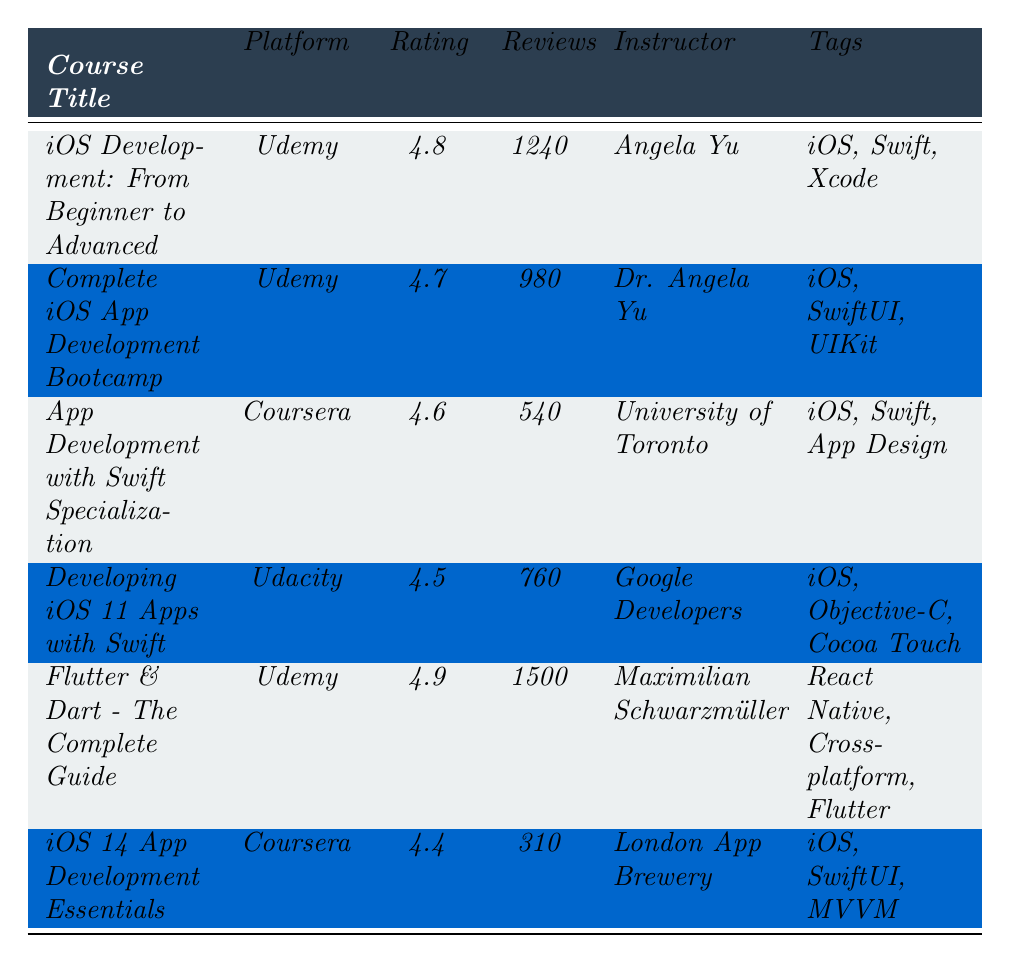What is the highest rating among the listed courses? The highest rating can be found by comparing the ratings of all courses in the table. The courses have ratings of 4.8, 4.7, 4.6, 4.5, 4.9, and 4.4. The highest value is 4.9, which belongs to the course "Flutter & Dart - The Complete Guide."
Answer: 4.9 Which platform has the most courses listed in the table? To find the platform with the most courses, we count how many times each platform appears in the table. Udemy appears four times, Coursera appears twice, and Udacity appears once. Therefore, Udemy has the most courses listed.
Answer: Udemy What is the average rating of all courses listed in the table? First, we add up all the ratings: 4.8 + 4.7 + 4.6 + 4.5 + 4.9 + 4.4 = 29.9. There are 6 courses, so we divide the total rating by the number of courses, which gives us 29.9 / 6 = 4.9833. Rounding to one decimal place, the average rating is 4.8.
Answer: 4.8 Are there any courses taught by the same instructor? By examining the "Instructor" column, we see that the courses "iOS Development: From Beginner to Advanced" and "Complete iOS App Development Bootcamp" are both taught by Angela Yu and Dr. Angela Yu. This indicates that there are course offerings from the same instructor.
Answer: Yes Which course has the least number of reviews? To find the course with the least reviews, we look at the "Reviews" column and get the values: 1240, 980, 540, 760, 1500, and 310. The smallest value is 310, corresponding to "iOS 14 App Development Essentials."
Answer: iOS 14 App Development Essentials What is the difference in average ratings between courses on Udemy and Coursera? First, we calculate the average rating for Udemy courses: (4.8 + 4.7 + 4.9) / 3 = 4.8. For Coursera, the ratings are (4.6 + 4.4) / 2 = 4.5. The difference is 4.8 - 4.5 = 0.3.
Answer: 0.3 Which course has the highest number of reviews and what is that number? By looking at the "Reviews" column, the reviews are: 1240, 980, 540, 760, 1500, and 310. The highest number is 1500, which belongs to the course "Flutter & Dart - The Complete Guide."
Answer: 1500 Are all courses rated above 4.0? We check each course rating: 4.8, 4.7, 4.6, 4.5, 4.9, and 4.4. Since all ratings are above 4.0, we can conclude that each course maintains a rating above this threshold.
Answer: Yes How many different tags are used across all courses? The tags for the courses are: iOS, Swift, Xcode, SwiftUI, UIKit, App Design, Objective-C, Cocoa Touch, React Native, Cross-platform, Flutter, and MVVM. Counting these unique tags gives us a total of 11 distinct tags.
Answer: 11 What proportion of the total reviews come from the course with the most reviews? The total number of reviews is 1240 + 980 + 540 + 760 + 1500 + 310 = 5320. The course with the most reviews, "Flutter & Dart - The Complete Guide," has 1500 reviews. Therefore, the proportion is 1500 / 5320 = 0.281 or 28.1%.
Answer: 28.1% 